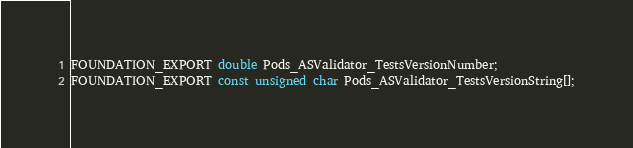<code> <loc_0><loc_0><loc_500><loc_500><_C_>

FOUNDATION_EXPORT double Pods_ASValidator_TestsVersionNumber;
FOUNDATION_EXPORT const unsigned char Pods_ASValidator_TestsVersionString[];

</code> 